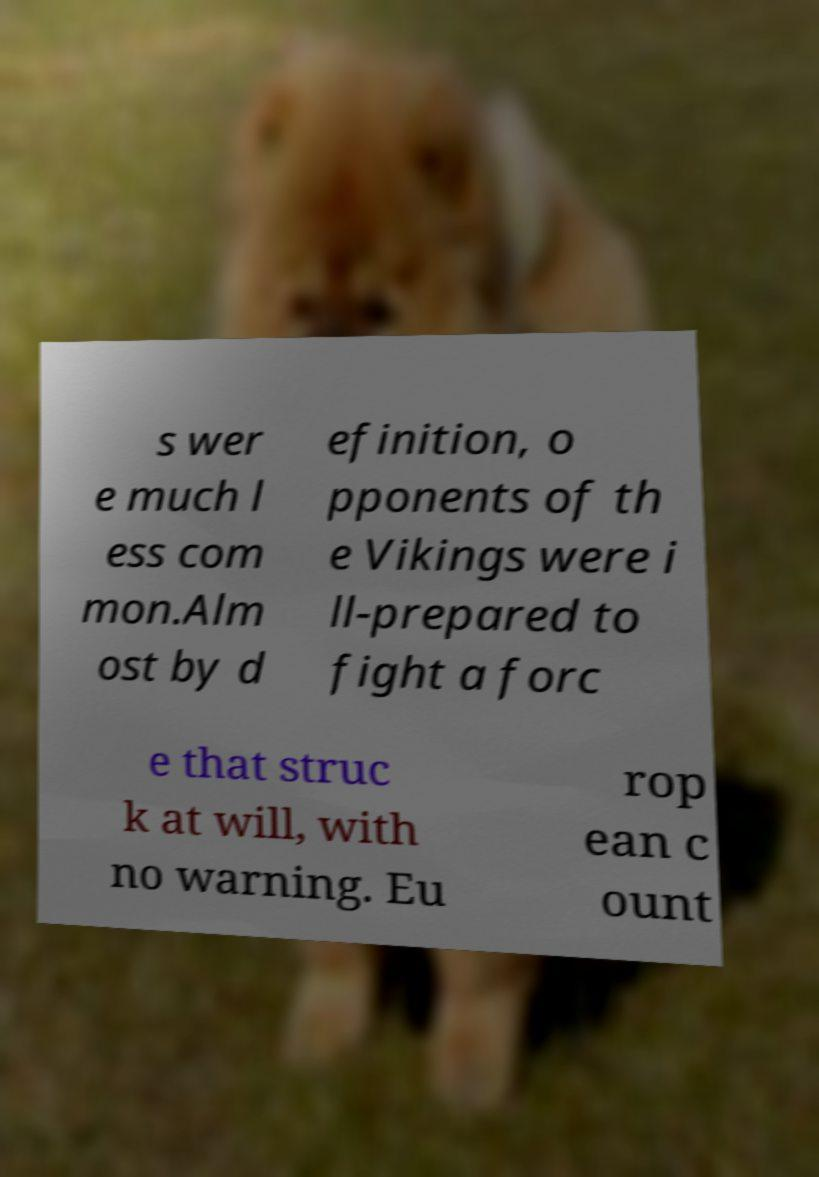What messages or text are displayed in this image? I need them in a readable, typed format. s wer e much l ess com mon.Alm ost by d efinition, o pponents of th e Vikings were i ll-prepared to fight a forc e that struc k at will, with no warning. Eu rop ean c ount 